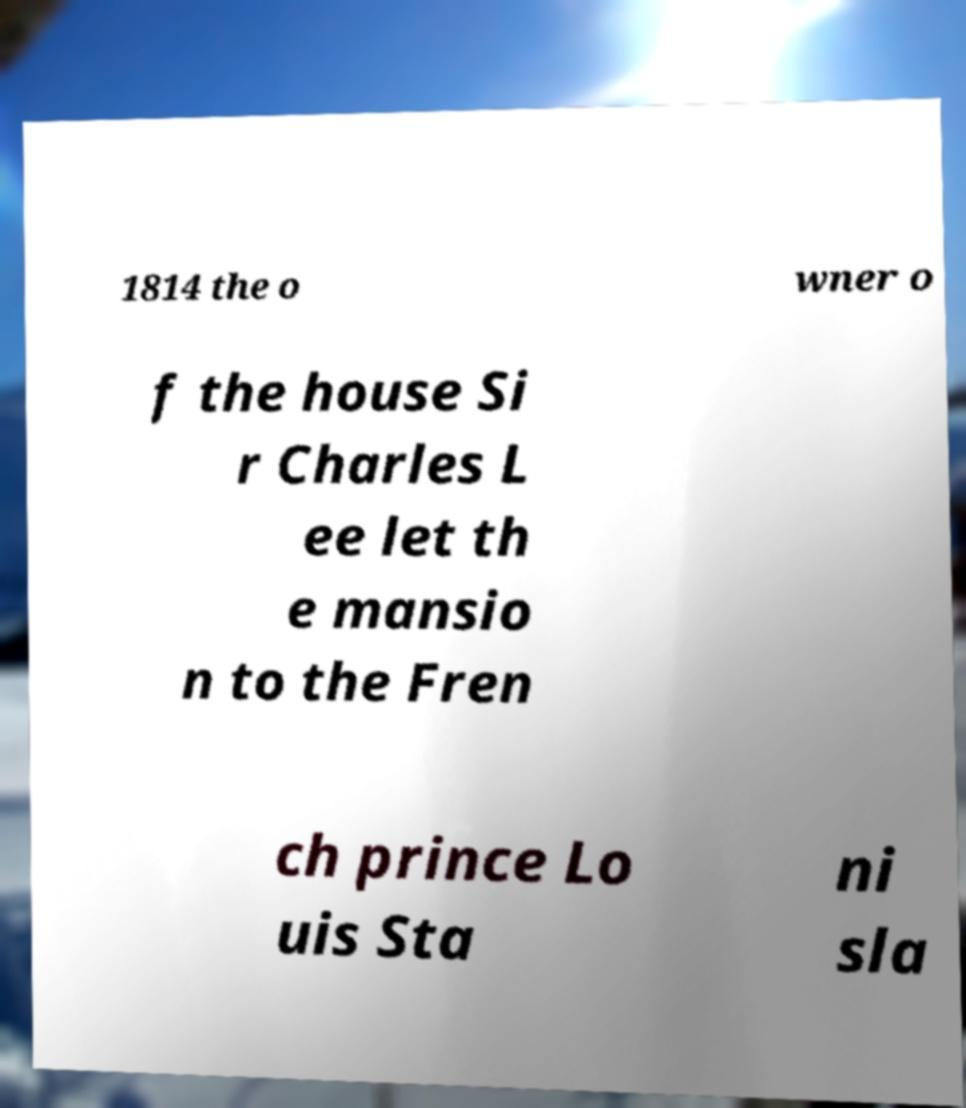What messages or text are displayed in this image? I need them in a readable, typed format. 1814 the o wner o f the house Si r Charles L ee let th e mansio n to the Fren ch prince Lo uis Sta ni sla 